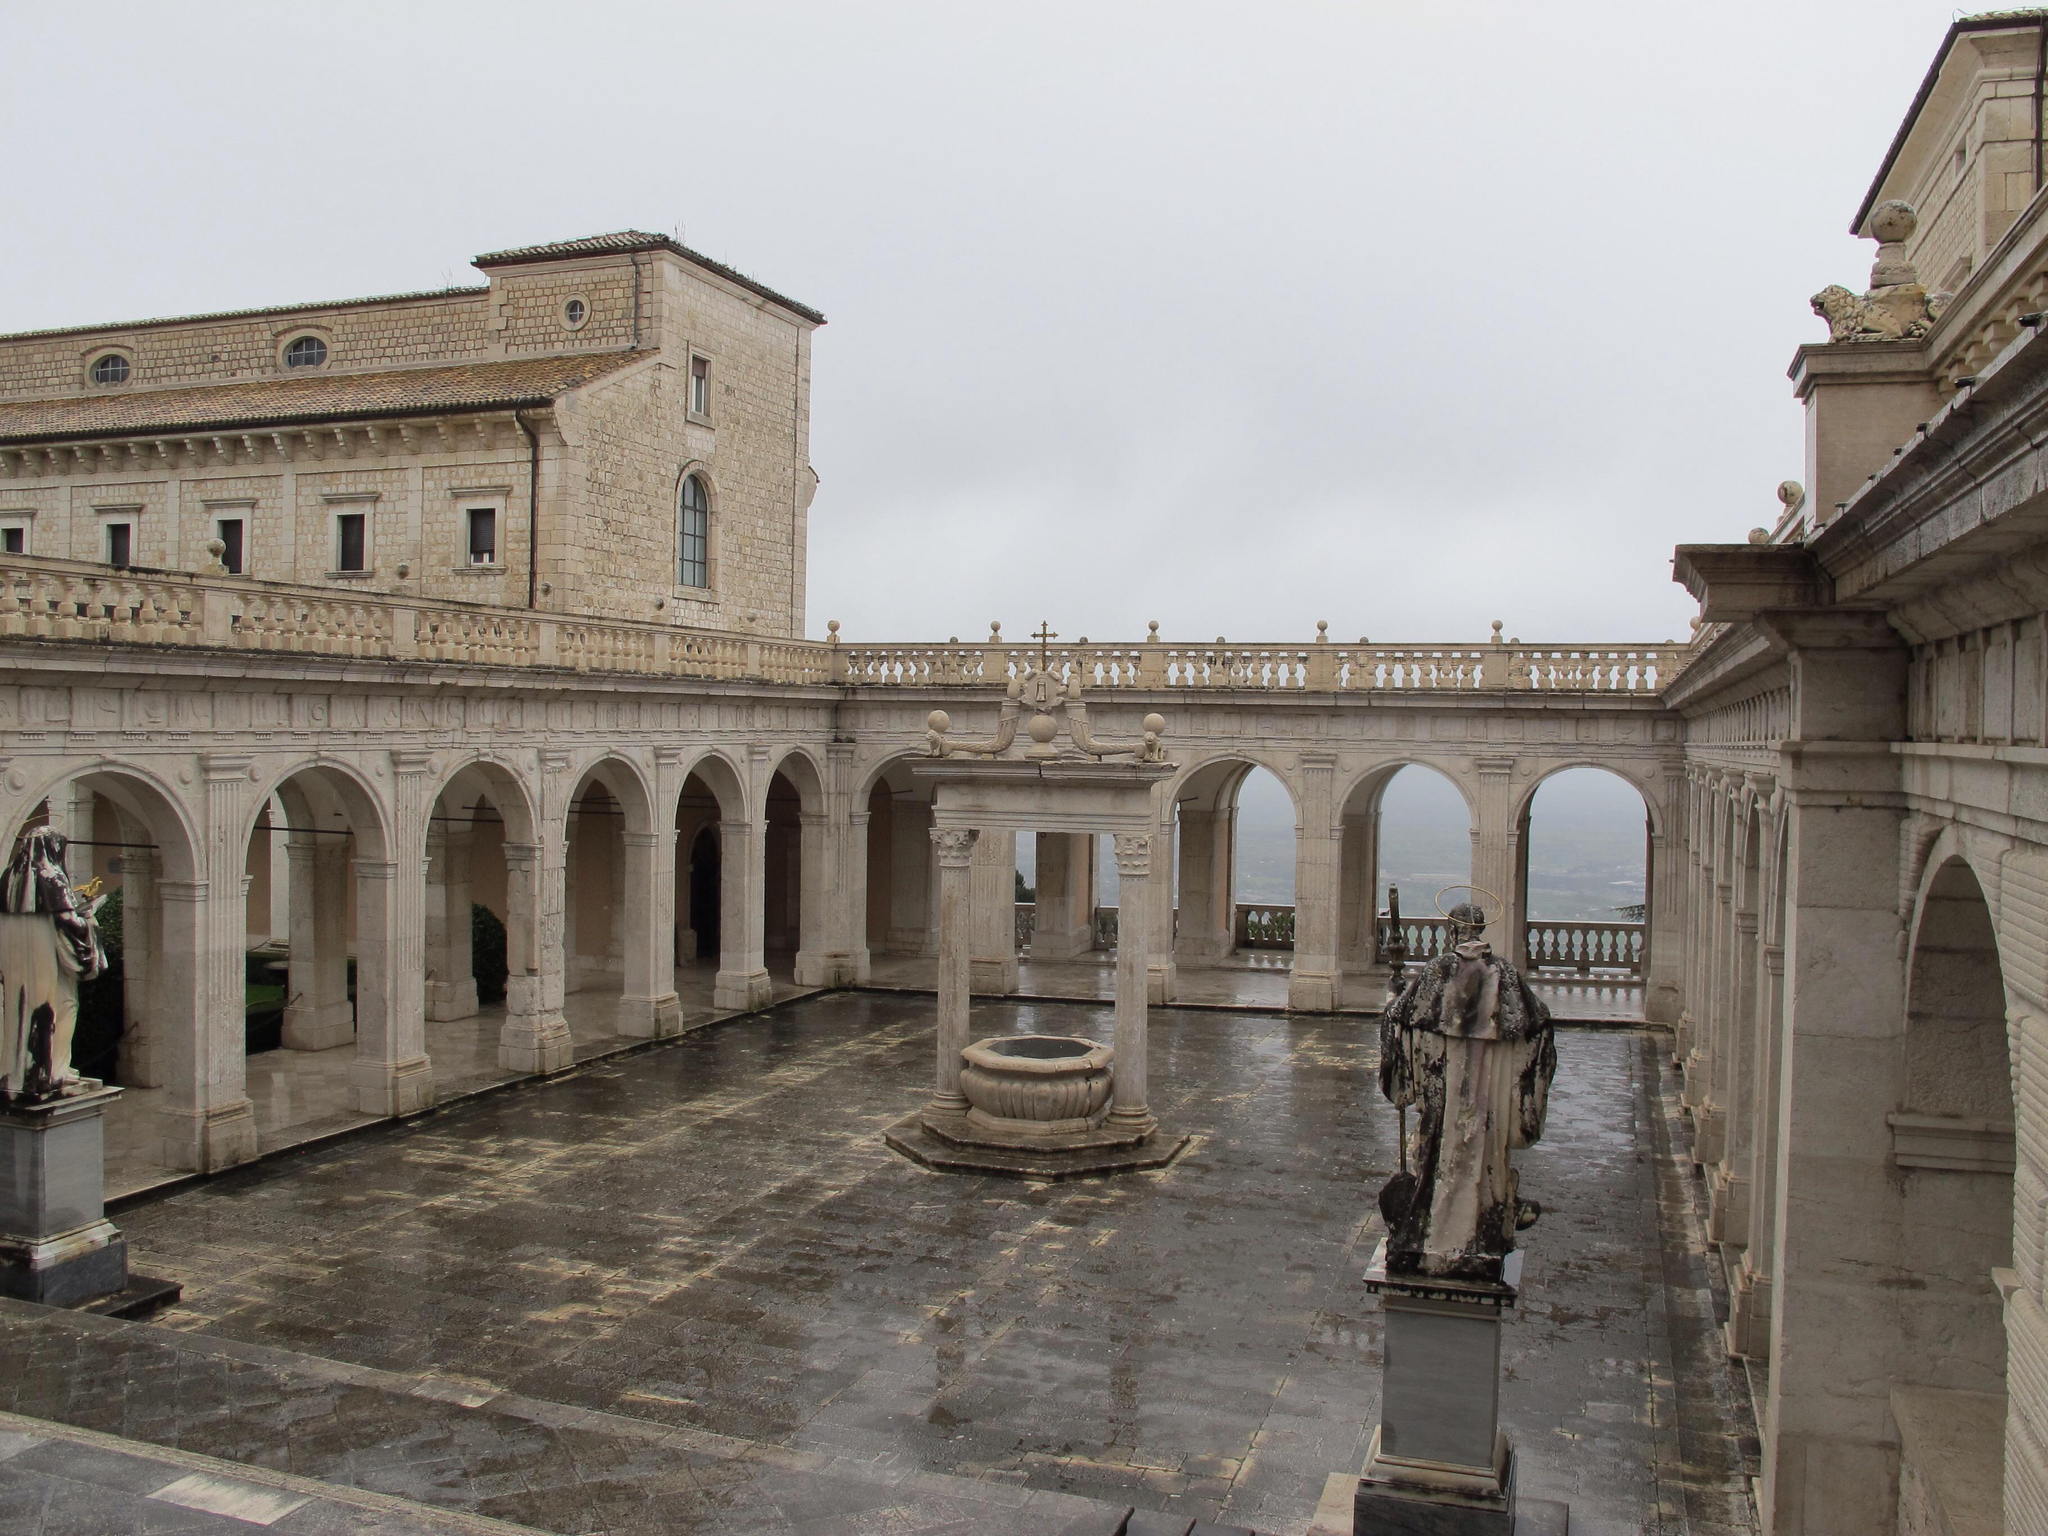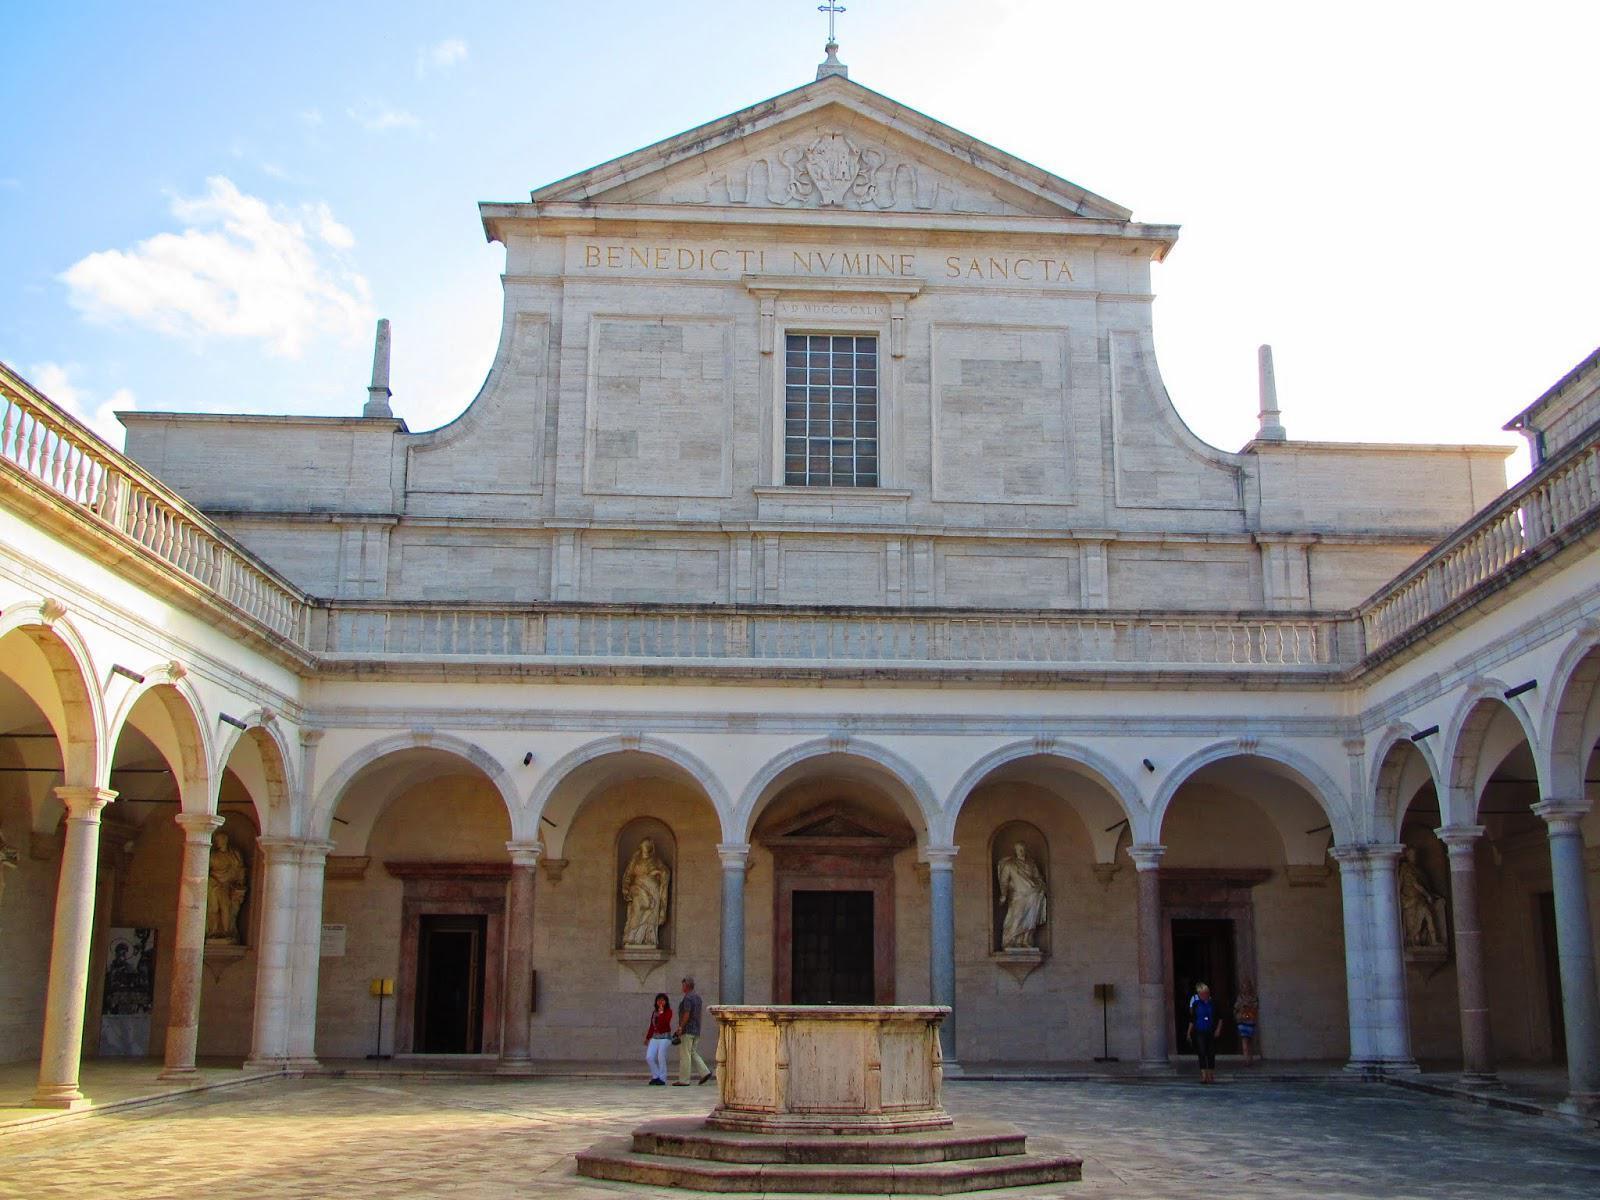The first image is the image on the left, the second image is the image on the right. For the images displayed, is the sentence "An image shows a stone-floored courtyard surrounded by arches, with a view through the arches into an empty distance." factually correct? Answer yes or no. Yes. The first image is the image on the left, the second image is the image on the right. Analyze the images presented: Is the assertion "The building in the image on the left is surrounded by lush greenery." valid? Answer yes or no. No. 